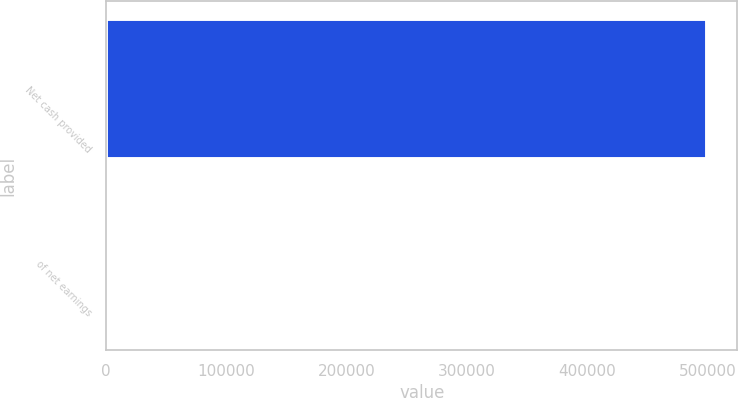Convert chart to OTSL. <chart><loc_0><loc_0><loc_500><loc_500><bar_chart><fcel>Net cash provided<fcel>of net earnings<nl><fcel>499392<fcel>101.1<nl></chart> 